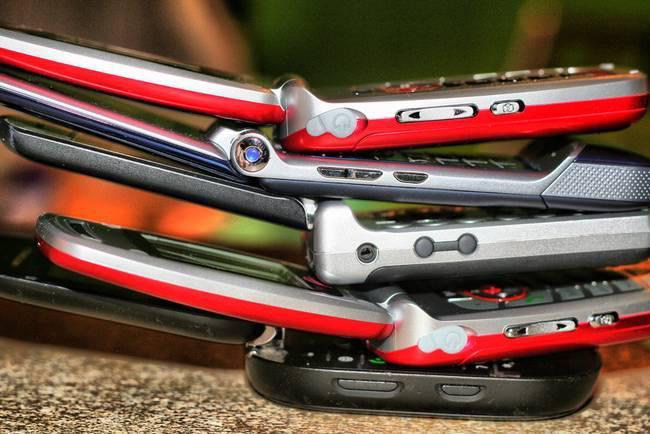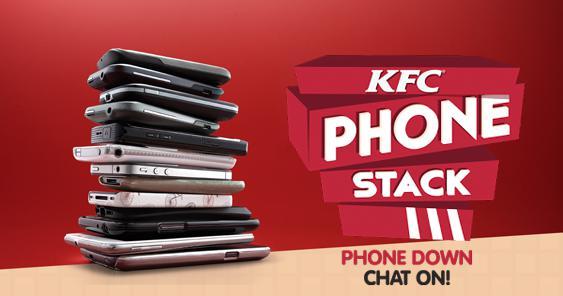The first image is the image on the left, the second image is the image on the right. For the images displayed, is the sentence "The phones in each of the image are stacked upon each other." factually correct? Answer yes or no. Yes. The first image is the image on the left, the second image is the image on the right. Given the left and right images, does the statement "There are more phones in the left image than in the right image." hold true? Answer yes or no. No. 